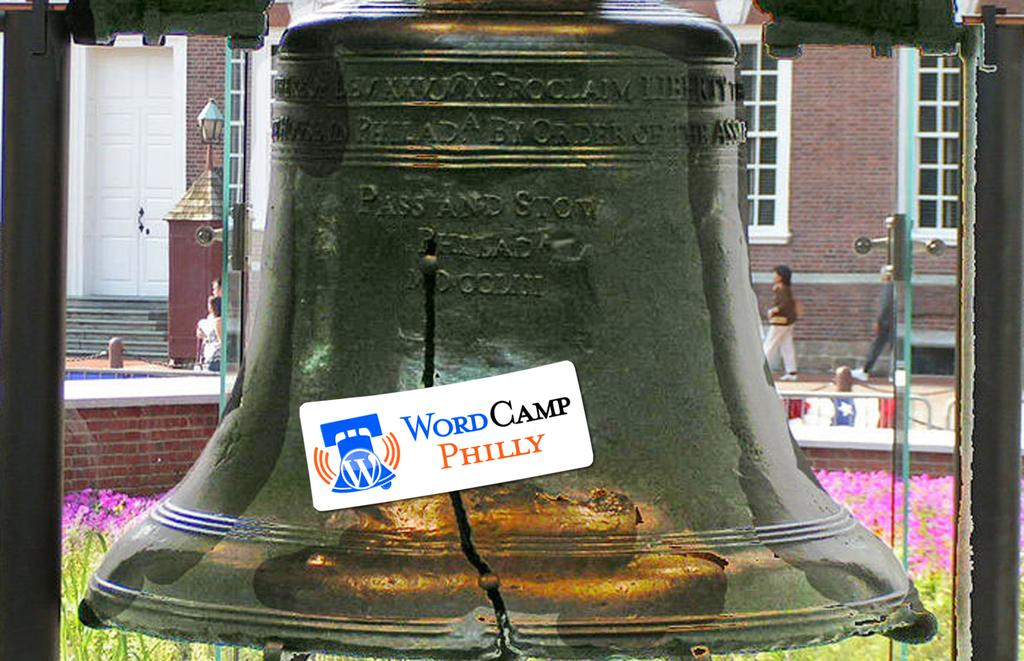What object can be seen in the picture? There is a bell in the picture. Can you describe the condition of the bell? The bell has a crack. Is there any text on the bell? Yes, there is writing on the bell. What can be seen in the background of the picture? There are people and a building in the background of the picture. What type of glass is being used to write on the bell? There is no glass present in the image, and the writing is not being done on the bell with any glass object. 